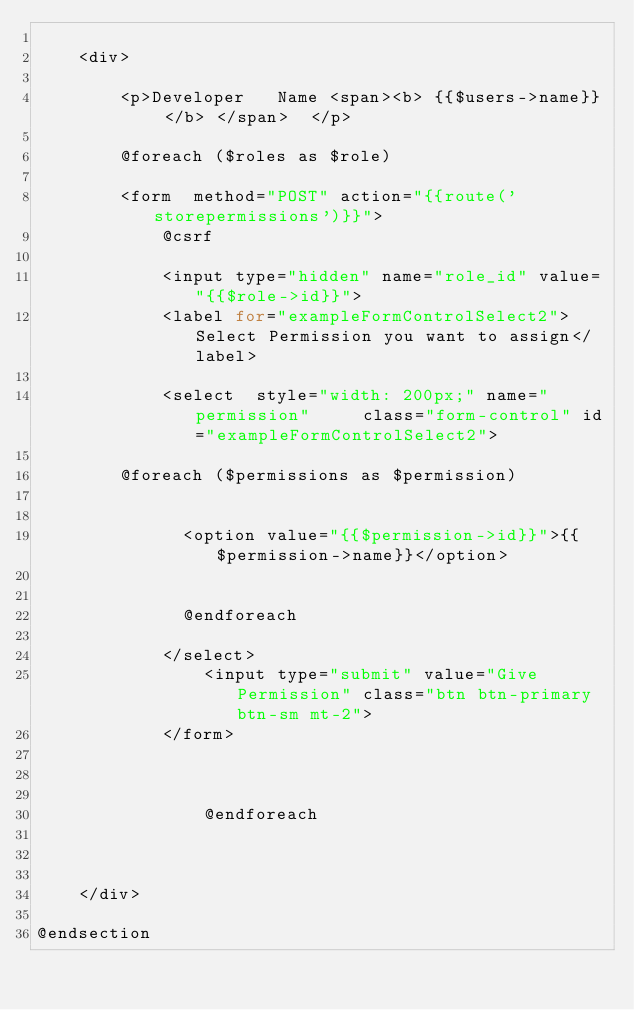Convert code to text. <code><loc_0><loc_0><loc_500><loc_500><_PHP_>    
    <div>

        <p>Developer   Name <span><b> {{$users->name}} </b> </span>  </p>

        @foreach ($roles as $role)
        
        <form  method="POST" action="{{route('storepermissions')}}">
            @csrf
            
            <input type="hidden" name="role_id" value="{{$role->id}}">
            <label for="exampleFormControlSelect2">Select Permission you want to assign</label>
            
            <select  style="width: 200px;" name="permission"     class="form-control" id="exampleFormControlSelect2">
              
        @foreach ($permissions as $permission)
        
   
              <option value="{{$permission->id}}">{{$permission->name}}</option>
             
              
              @endforeach
              
            </select>
                <input type="submit" value="Give Permission" class="btn btn-primary btn-sm mt-2">
            </form>
                
                   

                @endforeach

          

    </div>

@endsection</code> 